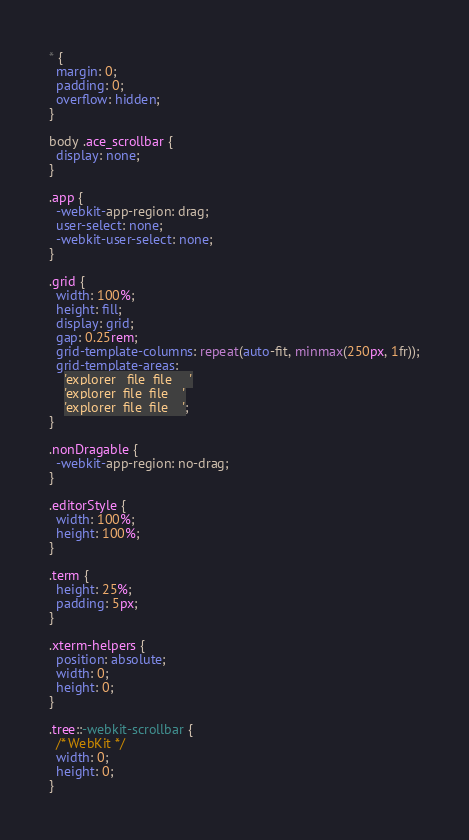Convert code to text. <code><loc_0><loc_0><loc_500><loc_500><_CSS_>* {
  margin: 0;
  padding: 0;
  overflow: hidden;
}

body .ace_scrollbar {
  display: none;
}

.app {
  -webkit-app-region: drag;
  user-select: none;
  -webkit-user-select: none;
}

.grid {
  width: 100%;
  height: fill;
  display: grid;
  gap: 0.25rem;
  grid-template-columns: repeat(auto-fit, minmax(250px, 1fr));
  grid-template-areas:
    'explorer   file  file     '
    'explorer  file  file    '
    'explorer  file  file    ';
}

.nonDragable {
  -webkit-app-region: no-drag;
}

.editorStyle {
  width: 100%;
  height: 100%;
}

.term {
  height: 25%;
  padding: 5px;
}

.xterm-helpers {
  position: absolute;
  width: 0;
  height: 0;
}

.tree::-webkit-scrollbar {
  /* WebKit */
  width: 0;
  height: 0;
}</code> 